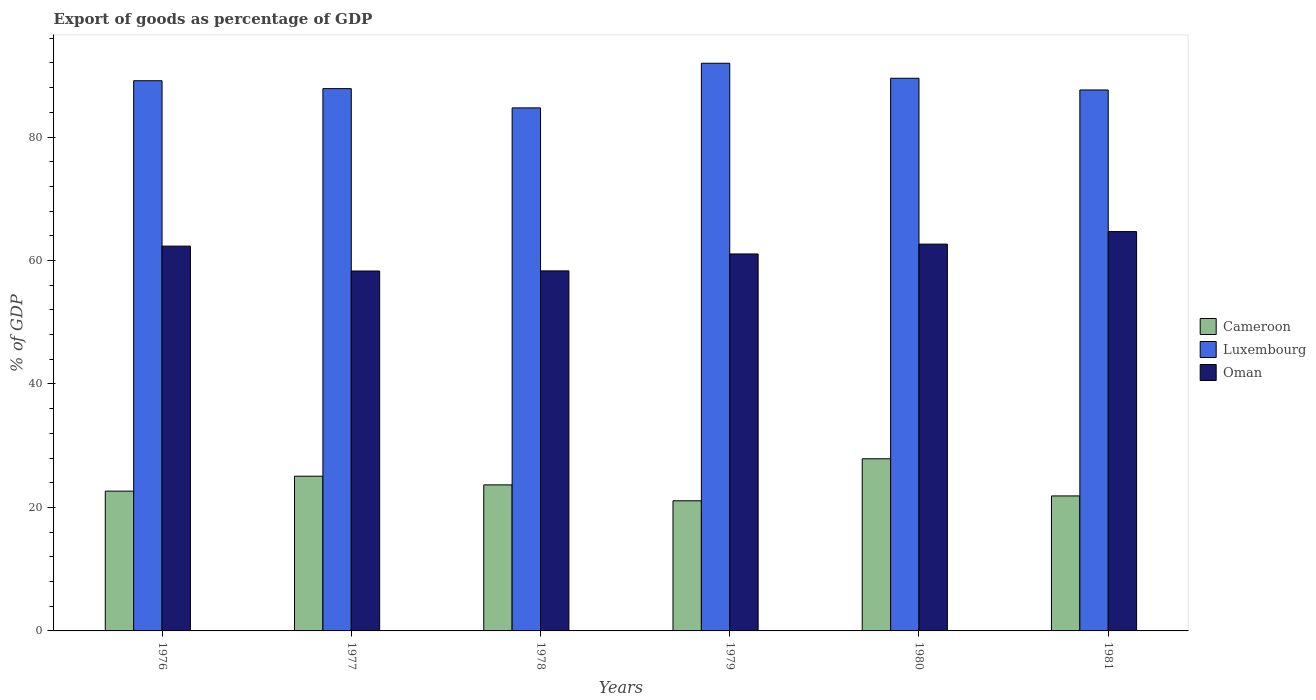How many different coloured bars are there?
Offer a very short reply. 3. How many groups of bars are there?
Your response must be concise. 6. Are the number of bars per tick equal to the number of legend labels?
Give a very brief answer. Yes. How many bars are there on the 2nd tick from the left?
Offer a terse response. 3. What is the label of the 6th group of bars from the left?
Make the answer very short. 1981. What is the export of goods as percentage of GDP in Luxembourg in 1977?
Give a very brief answer. 87.84. Across all years, what is the maximum export of goods as percentage of GDP in Oman?
Offer a very short reply. 64.69. Across all years, what is the minimum export of goods as percentage of GDP in Luxembourg?
Give a very brief answer. 84.72. In which year was the export of goods as percentage of GDP in Cameroon maximum?
Give a very brief answer. 1980. In which year was the export of goods as percentage of GDP in Cameroon minimum?
Your answer should be very brief. 1979. What is the total export of goods as percentage of GDP in Cameroon in the graph?
Offer a terse response. 142.19. What is the difference between the export of goods as percentage of GDP in Oman in 1979 and that in 1981?
Keep it short and to the point. -3.62. What is the difference between the export of goods as percentage of GDP in Luxembourg in 1978 and the export of goods as percentage of GDP in Oman in 1980?
Your response must be concise. 22.07. What is the average export of goods as percentage of GDP in Luxembourg per year?
Offer a very short reply. 88.47. In the year 1978, what is the difference between the export of goods as percentage of GDP in Cameroon and export of goods as percentage of GDP in Oman?
Keep it short and to the point. -34.66. In how many years, is the export of goods as percentage of GDP in Cameroon greater than 36 %?
Your answer should be compact. 0. What is the ratio of the export of goods as percentage of GDP in Oman in 1978 to that in 1980?
Make the answer very short. 0.93. What is the difference between the highest and the second highest export of goods as percentage of GDP in Cameroon?
Make the answer very short. 2.82. What is the difference between the highest and the lowest export of goods as percentage of GDP in Oman?
Provide a succinct answer. 6.39. In how many years, is the export of goods as percentage of GDP in Luxembourg greater than the average export of goods as percentage of GDP in Luxembourg taken over all years?
Give a very brief answer. 3. What does the 2nd bar from the left in 1980 represents?
Offer a terse response. Luxembourg. What does the 3rd bar from the right in 1978 represents?
Your answer should be compact. Cameroon. What is the difference between two consecutive major ticks on the Y-axis?
Make the answer very short. 20. Does the graph contain grids?
Offer a terse response. No. Where does the legend appear in the graph?
Your answer should be compact. Center right. What is the title of the graph?
Keep it short and to the point. Export of goods as percentage of GDP. What is the label or title of the X-axis?
Offer a very short reply. Years. What is the label or title of the Y-axis?
Make the answer very short. % of GDP. What is the % of GDP of Cameroon in 1976?
Your response must be concise. 22.64. What is the % of GDP of Luxembourg in 1976?
Keep it short and to the point. 89.12. What is the % of GDP of Oman in 1976?
Your answer should be compact. 62.33. What is the % of GDP of Cameroon in 1977?
Your answer should be very brief. 25.06. What is the % of GDP of Luxembourg in 1977?
Your response must be concise. 87.84. What is the % of GDP of Oman in 1977?
Offer a very short reply. 58.3. What is the % of GDP of Cameroon in 1978?
Give a very brief answer. 23.66. What is the % of GDP of Luxembourg in 1978?
Make the answer very short. 84.72. What is the % of GDP of Oman in 1978?
Keep it short and to the point. 58.32. What is the % of GDP in Cameroon in 1979?
Provide a short and direct response. 21.08. What is the % of GDP in Luxembourg in 1979?
Give a very brief answer. 91.95. What is the % of GDP in Oman in 1979?
Provide a short and direct response. 61.06. What is the % of GDP of Cameroon in 1980?
Give a very brief answer. 27.88. What is the % of GDP in Luxembourg in 1980?
Make the answer very short. 89.52. What is the % of GDP of Oman in 1980?
Ensure brevity in your answer.  62.66. What is the % of GDP of Cameroon in 1981?
Ensure brevity in your answer.  21.87. What is the % of GDP in Luxembourg in 1981?
Provide a succinct answer. 87.63. What is the % of GDP of Oman in 1981?
Your answer should be very brief. 64.69. Across all years, what is the maximum % of GDP in Cameroon?
Give a very brief answer. 27.88. Across all years, what is the maximum % of GDP in Luxembourg?
Keep it short and to the point. 91.95. Across all years, what is the maximum % of GDP in Oman?
Give a very brief answer. 64.69. Across all years, what is the minimum % of GDP of Cameroon?
Give a very brief answer. 21.08. Across all years, what is the minimum % of GDP of Luxembourg?
Your response must be concise. 84.72. Across all years, what is the minimum % of GDP of Oman?
Your answer should be very brief. 58.3. What is the total % of GDP of Cameroon in the graph?
Your answer should be compact. 142.19. What is the total % of GDP of Luxembourg in the graph?
Provide a short and direct response. 530.79. What is the total % of GDP in Oman in the graph?
Give a very brief answer. 367.36. What is the difference between the % of GDP in Cameroon in 1976 and that in 1977?
Provide a short and direct response. -2.42. What is the difference between the % of GDP of Luxembourg in 1976 and that in 1977?
Provide a succinct answer. 1.28. What is the difference between the % of GDP in Oman in 1976 and that in 1977?
Offer a very short reply. 4.03. What is the difference between the % of GDP of Cameroon in 1976 and that in 1978?
Offer a very short reply. -1.01. What is the difference between the % of GDP of Luxembourg in 1976 and that in 1978?
Your response must be concise. 4.4. What is the difference between the % of GDP of Oman in 1976 and that in 1978?
Your answer should be compact. 4.01. What is the difference between the % of GDP in Cameroon in 1976 and that in 1979?
Provide a short and direct response. 1.56. What is the difference between the % of GDP in Luxembourg in 1976 and that in 1979?
Give a very brief answer. -2.83. What is the difference between the % of GDP in Oman in 1976 and that in 1979?
Provide a short and direct response. 1.27. What is the difference between the % of GDP in Cameroon in 1976 and that in 1980?
Make the answer very short. -5.24. What is the difference between the % of GDP in Luxembourg in 1976 and that in 1980?
Keep it short and to the point. -0.4. What is the difference between the % of GDP in Oman in 1976 and that in 1980?
Offer a terse response. -0.33. What is the difference between the % of GDP of Cameroon in 1976 and that in 1981?
Provide a short and direct response. 0.78. What is the difference between the % of GDP of Luxembourg in 1976 and that in 1981?
Your answer should be very brief. 1.49. What is the difference between the % of GDP in Oman in 1976 and that in 1981?
Your answer should be compact. -2.36. What is the difference between the % of GDP of Cameroon in 1977 and that in 1978?
Your answer should be very brief. 1.4. What is the difference between the % of GDP in Luxembourg in 1977 and that in 1978?
Offer a very short reply. 3.12. What is the difference between the % of GDP of Oman in 1977 and that in 1978?
Offer a terse response. -0.02. What is the difference between the % of GDP in Cameroon in 1977 and that in 1979?
Provide a succinct answer. 3.98. What is the difference between the % of GDP of Luxembourg in 1977 and that in 1979?
Offer a very short reply. -4.11. What is the difference between the % of GDP of Oman in 1977 and that in 1979?
Keep it short and to the point. -2.76. What is the difference between the % of GDP of Cameroon in 1977 and that in 1980?
Keep it short and to the point. -2.82. What is the difference between the % of GDP in Luxembourg in 1977 and that in 1980?
Provide a short and direct response. -1.68. What is the difference between the % of GDP of Oman in 1977 and that in 1980?
Offer a terse response. -4.36. What is the difference between the % of GDP of Cameroon in 1977 and that in 1981?
Your answer should be compact. 3.19. What is the difference between the % of GDP of Luxembourg in 1977 and that in 1981?
Your answer should be very brief. 0.21. What is the difference between the % of GDP in Oman in 1977 and that in 1981?
Make the answer very short. -6.39. What is the difference between the % of GDP in Cameroon in 1978 and that in 1979?
Your answer should be very brief. 2.58. What is the difference between the % of GDP of Luxembourg in 1978 and that in 1979?
Give a very brief answer. -7.23. What is the difference between the % of GDP of Oman in 1978 and that in 1979?
Provide a succinct answer. -2.74. What is the difference between the % of GDP of Cameroon in 1978 and that in 1980?
Your answer should be very brief. -4.23. What is the difference between the % of GDP in Luxembourg in 1978 and that in 1980?
Provide a short and direct response. -4.8. What is the difference between the % of GDP of Oman in 1978 and that in 1980?
Ensure brevity in your answer.  -4.34. What is the difference between the % of GDP of Cameroon in 1978 and that in 1981?
Offer a terse response. 1.79. What is the difference between the % of GDP of Luxembourg in 1978 and that in 1981?
Your answer should be compact. -2.9. What is the difference between the % of GDP of Oman in 1978 and that in 1981?
Your response must be concise. -6.37. What is the difference between the % of GDP of Cameroon in 1979 and that in 1980?
Make the answer very short. -6.81. What is the difference between the % of GDP of Luxembourg in 1979 and that in 1980?
Ensure brevity in your answer.  2.43. What is the difference between the % of GDP of Oman in 1979 and that in 1980?
Offer a very short reply. -1.6. What is the difference between the % of GDP in Cameroon in 1979 and that in 1981?
Provide a succinct answer. -0.79. What is the difference between the % of GDP in Luxembourg in 1979 and that in 1981?
Your answer should be compact. 4.33. What is the difference between the % of GDP in Oman in 1979 and that in 1981?
Your answer should be very brief. -3.62. What is the difference between the % of GDP in Cameroon in 1980 and that in 1981?
Your answer should be very brief. 6.02. What is the difference between the % of GDP of Luxembourg in 1980 and that in 1981?
Your answer should be compact. 1.89. What is the difference between the % of GDP in Oman in 1980 and that in 1981?
Your answer should be compact. -2.03. What is the difference between the % of GDP in Cameroon in 1976 and the % of GDP in Luxembourg in 1977?
Your response must be concise. -65.2. What is the difference between the % of GDP of Cameroon in 1976 and the % of GDP of Oman in 1977?
Give a very brief answer. -35.66. What is the difference between the % of GDP in Luxembourg in 1976 and the % of GDP in Oman in 1977?
Ensure brevity in your answer.  30.82. What is the difference between the % of GDP of Cameroon in 1976 and the % of GDP of Luxembourg in 1978?
Give a very brief answer. -62.08. What is the difference between the % of GDP in Cameroon in 1976 and the % of GDP in Oman in 1978?
Your answer should be very brief. -35.68. What is the difference between the % of GDP in Luxembourg in 1976 and the % of GDP in Oman in 1978?
Keep it short and to the point. 30.8. What is the difference between the % of GDP of Cameroon in 1976 and the % of GDP of Luxembourg in 1979?
Make the answer very short. -69.31. What is the difference between the % of GDP in Cameroon in 1976 and the % of GDP in Oman in 1979?
Make the answer very short. -38.42. What is the difference between the % of GDP of Luxembourg in 1976 and the % of GDP of Oman in 1979?
Your answer should be very brief. 28.06. What is the difference between the % of GDP in Cameroon in 1976 and the % of GDP in Luxembourg in 1980?
Give a very brief answer. -66.88. What is the difference between the % of GDP in Cameroon in 1976 and the % of GDP in Oman in 1980?
Offer a very short reply. -40.02. What is the difference between the % of GDP of Luxembourg in 1976 and the % of GDP of Oman in 1980?
Your response must be concise. 26.46. What is the difference between the % of GDP of Cameroon in 1976 and the % of GDP of Luxembourg in 1981?
Keep it short and to the point. -64.99. What is the difference between the % of GDP in Cameroon in 1976 and the % of GDP in Oman in 1981?
Make the answer very short. -42.04. What is the difference between the % of GDP of Luxembourg in 1976 and the % of GDP of Oman in 1981?
Provide a short and direct response. 24.44. What is the difference between the % of GDP in Cameroon in 1977 and the % of GDP in Luxembourg in 1978?
Your answer should be very brief. -59.66. What is the difference between the % of GDP in Cameroon in 1977 and the % of GDP in Oman in 1978?
Give a very brief answer. -33.26. What is the difference between the % of GDP of Luxembourg in 1977 and the % of GDP of Oman in 1978?
Your answer should be compact. 29.52. What is the difference between the % of GDP in Cameroon in 1977 and the % of GDP in Luxembourg in 1979?
Offer a terse response. -66.89. What is the difference between the % of GDP of Cameroon in 1977 and the % of GDP of Oman in 1979?
Give a very brief answer. -36. What is the difference between the % of GDP of Luxembourg in 1977 and the % of GDP of Oman in 1979?
Your answer should be very brief. 26.78. What is the difference between the % of GDP in Cameroon in 1977 and the % of GDP in Luxembourg in 1980?
Your response must be concise. -64.46. What is the difference between the % of GDP of Cameroon in 1977 and the % of GDP of Oman in 1980?
Your answer should be compact. -37.6. What is the difference between the % of GDP of Luxembourg in 1977 and the % of GDP of Oman in 1980?
Your answer should be very brief. 25.18. What is the difference between the % of GDP of Cameroon in 1977 and the % of GDP of Luxembourg in 1981?
Offer a terse response. -62.57. What is the difference between the % of GDP in Cameroon in 1977 and the % of GDP in Oman in 1981?
Your answer should be very brief. -39.63. What is the difference between the % of GDP in Luxembourg in 1977 and the % of GDP in Oman in 1981?
Your answer should be compact. 23.16. What is the difference between the % of GDP of Cameroon in 1978 and the % of GDP of Luxembourg in 1979?
Offer a very short reply. -68.3. What is the difference between the % of GDP of Cameroon in 1978 and the % of GDP of Oman in 1979?
Provide a short and direct response. -37.41. What is the difference between the % of GDP of Luxembourg in 1978 and the % of GDP of Oman in 1979?
Your answer should be very brief. 23.66. What is the difference between the % of GDP of Cameroon in 1978 and the % of GDP of Luxembourg in 1980?
Provide a short and direct response. -65.87. What is the difference between the % of GDP in Cameroon in 1978 and the % of GDP in Oman in 1980?
Your response must be concise. -39. What is the difference between the % of GDP of Luxembourg in 1978 and the % of GDP of Oman in 1980?
Your answer should be very brief. 22.07. What is the difference between the % of GDP of Cameroon in 1978 and the % of GDP of Luxembourg in 1981?
Give a very brief answer. -63.97. What is the difference between the % of GDP of Cameroon in 1978 and the % of GDP of Oman in 1981?
Offer a terse response. -41.03. What is the difference between the % of GDP of Luxembourg in 1978 and the % of GDP of Oman in 1981?
Keep it short and to the point. 20.04. What is the difference between the % of GDP of Cameroon in 1979 and the % of GDP of Luxembourg in 1980?
Make the answer very short. -68.44. What is the difference between the % of GDP in Cameroon in 1979 and the % of GDP in Oman in 1980?
Make the answer very short. -41.58. What is the difference between the % of GDP in Luxembourg in 1979 and the % of GDP in Oman in 1980?
Offer a very short reply. 29.29. What is the difference between the % of GDP of Cameroon in 1979 and the % of GDP of Luxembourg in 1981?
Make the answer very short. -66.55. What is the difference between the % of GDP in Cameroon in 1979 and the % of GDP in Oman in 1981?
Provide a short and direct response. -43.61. What is the difference between the % of GDP of Luxembourg in 1979 and the % of GDP of Oman in 1981?
Ensure brevity in your answer.  27.27. What is the difference between the % of GDP in Cameroon in 1980 and the % of GDP in Luxembourg in 1981?
Your response must be concise. -59.74. What is the difference between the % of GDP of Cameroon in 1980 and the % of GDP of Oman in 1981?
Provide a succinct answer. -36.8. What is the difference between the % of GDP of Luxembourg in 1980 and the % of GDP of Oman in 1981?
Make the answer very short. 24.84. What is the average % of GDP in Cameroon per year?
Offer a terse response. 23.7. What is the average % of GDP of Luxembourg per year?
Keep it short and to the point. 88.47. What is the average % of GDP in Oman per year?
Provide a succinct answer. 61.23. In the year 1976, what is the difference between the % of GDP of Cameroon and % of GDP of Luxembourg?
Your response must be concise. -66.48. In the year 1976, what is the difference between the % of GDP of Cameroon and % of GDP of Oman?
Offer a terse response. -39.69. In the year 1976, what is the difference between the % of GDP of Luxembourg and % of GDP of Oman?
Ensure brevity in your answer.  26.79. In the year 1977, what is the difference between the % of GDP in Cameroon and % of GDP in Luxembourg?
Provide a succinct answer. -62.78. In the year 1977, what is the difference between the % of GDP in Cameroon and % of GDP in Oman?
Make the answer very short. -33.24. In the year 1977, what is the difference between the % of GDP in Luxembourg and % of GDP in Oman?
Offer a terse response. 29.54. In the year 1978, what is the difference between the % of GDP in Cameroon and % of GDP in Luxembourg?
Your answer should be very brief. -61.07. In the year 1978, what is the difference between the % of GDP in Cameroon and % of GDP in Oman?
Ensure brevity in your answer.  -34.66. In the year 1978, what is the difference between the % of GDP of Luxembourg and % of GDP of Oman?
Ensure brevity in your answer.  26.4. In the year 1979, what is the difference between the % of GDP in Cameroon and % of GDP in Luxembourg?
Keep it short and to the point. -70.87. In the year 1979, what is the difference between the % of GDP of Cameroon and % of GDP of Oman?
Provide a short and direct response. -39.98. In the year 1979, what is the difference between the % of GDP of Luxembourg and % of GDP of Oman?
Keep it short and to the point. 30.89. In the year 1980, what is the difference between the % of GDP in Cameroon and % of GDP in Luxembourg?
Give a very brief answer. -61.64. In the year 1980, what is the difference between the % of GDP of Cameroon and % of GDP of Oman?
Give a very brief answer. -34.77. In the year 1980, what is the difference between the % of GDP in Luxembourg and % of GDP in Oman?
Offer a terse response. 26.86. In the year 1981, what is the difference between the % of GDP of Cameroon and % of GDP of Luxembourg?
Offer a very short reply. -65.76. In the year 1981, what is the difference between the % of GDP in Cameroon and % of GDP in Oman?
Your answer should be very brief. -42.82. In the year 1981, what is the difference between the % of GDP in Luxembourg and % of GDP in Oman?
Give a very brief answer. 22.94. What is the ratio of the % of GDP of Cameroon in 1976 to that in 1977?
Keep it short and to the point. 0.9. What is the ratio of the % of GDP of Luxembourg in 1976 to that in 1977?
Provide a short and direct response. 1.01. What is the ratio of the % of GDP in Oman in 1976 to that in 1977?
Ensure brevity in your answer.  1.07. What is the ratio of the % of GDP in Cameroon in 1976 to that in 1978?
Offer a terse response. 0.96. What is the ratio of the % of GDP of Luxembourg in 1976 to that in 1978?
Your answer should be very brief. 1.05. What is the ratio of the % of GDP of Oman in 1976 to that in 1978?
Your response must be concise. 1.07. What is the ratio of the % of GDP in Cameroon in 1976 to that in 1979?
Your answer should be very brief. 1.07. What is the ratio of the % of GDP in Luxembourg in 1976 to that in 1979?
Make the answer very short. 0.97. What is the ratio of the % of GDP of Oman in 1976 to that in 1979?
Your answer should be compact. 1.02. What is the ratio of the % of GDP in Cameroon in 1976 to that in 1980?
Ensure brevity in your answer.  0.81. What is the ratio of the % of GDP of Luxembourg in 1976 to that in 1980?
Offer a terse response. 1. What is the ratio of the % of GDP of Cameroon in 1976 to that in 1981?
Keep it short and to the point. 1.04. What is the ratio of the % of GDP of Luxembourg in 1976 to that in 1981?
Your answer should be compact. 1.02. What is the ratio of the % of GDP in Oman in 1976 to that in 1981?
Offer a very short reply. 0.96. What is the ratio of the % of GDP in Cameroon in 1977 to that in 1978?
Offer a terse response. 1.06. What is the ratio of the % of GDP of Luxembourg in 1977 to that in 1978?
Provide a succinct answer. 1.04. What is the ratio of the % of GDP in Oman in 1977 to that in 1978?
Offer a terse response. 1. What is the ratio of the % of GDP in Cameroon in 1977 to that in 1979?
Keep it short and to the point. 1.19. What is the ratio of the % of GDP of Luxembourg in 1977 to that in 1979?
Offer a very short reply. 0.96. What is the ratio of the % of GDP in Oman in 1977 to that in 1979?
Ensure brevity in your answer.  0.95. What is the ratio of the % of GDP in Cameroon in 1977 to that in 1980?
Provide a short and direct response. 0.9. What is the ratio of the % of GDP of Luxembourg in 1977 to that in 1980?
Offer a terse response. 0.98. What is the ratio of the % of GDP of Oman in 1977 to that in 1980?
Offer a terse response. 0.93. What is the ratio of the % of GDP in Cameroon in 1977 to that in 1981?
Your answer should be compact. 1.15. What is the ratio of the % of GDP in Luxembourg in 1977 to that in 1981?
Provide a short and direct response. 1. What is the ratio of the % of GDP of Oman in 1977 to that in 1981?
Ensure brevity in your answer.  0.9. What is the ratio of the % of GDP of Cameroon in 1978 to that in 1979?
Your answer should be very brief. 1.12. What is the ratio of the % of GDP of Luxembourg in 1978 to that in 1979?
Provide a succinct answer. 0.92. What is the ratio of the % of GDP of Oman in 1978 to that in 1979?
Provide a short and direct response. 0.96. What is the ratio of the % of GDP of Cameroon in 1978 to that in 1980?
Keep it short and to the point. 0.85. What is the ratio of the % of GDP of Luxembourg in 1978 to that in 1980?
Offer a very short reply. 0.95. What is the ratio of the % of GDP of Oman in 1978 to that in 1980?
Ensure brevity in your answer.  0.93. What is the ratio of the % of GDP in Cameroon in 1978 to that in 1981?
Offer a very short reply. 1.08. What is the ratio of the % of GDP of Luxembourg in 1978 to that in 1981?
Your answer should be very brief. 0.97. What is the ratio of the % of GDP of Oman in 1978 to that in 1981?
Provide a succinct answer. 0.9. What is the ratio of the % of GDP in Cameroon in 1979 to that in 1980?
Offer a very short reply. 0.76. What is the ratio of the % of GDP in Luxembourg in 1979 to that in 1980?
Make the answer very short. 1.03. What is the ratio of the % of GDP in Oman in 1979 to that in 1980?
Make the answer very short. 0.97. What is the ratio of the % of GDP in Cameroon in 1979 to that in 1981?
Make the answer very short. 0.96. What is the ratio of the % of GDP of Luxembourg in 1979 to that in 1981?
Provide a short and direct response. 1.05. What is the ratio of the % of GDP of Oman in 1979 to that in 1981?
Your response must be concise. 0.94. What is the ratio of the % of GDP of Cameroon in 1980 to that in 1981?
Offer a terse response. 1.28. What is the ratio of the % of GDP of Luxembourg in 1980 to that in 1981?
Provide a short and direct response. 1.02. What is the ratio of the % of GDP in Oman in 1980 to that in 1981?
Offer a terse response. 0.97. What is the difference between the highest and the second highest % of GDP of Cameroon?
Your response must be concise. 2.82. What is the difference between the highest and the second highest % of GDP in Luxembourg?
Make the answer very short. 2.43. What is the difference between the highest and the second highest % of GDP of Oman?
Ensure brevity in your answer.  2.03. What is the difference between the highest and the lowest % of GDP in Cameroon?
Your answer should be very brief. 6.81. What is the difference between the highest and the lowest % of GDP of Luxembourg?
Offer a very short reply. 7.23. What is the difference between the highest and the lowest % of GDP in Oman?
Keep it short and to the point. 6.39. 